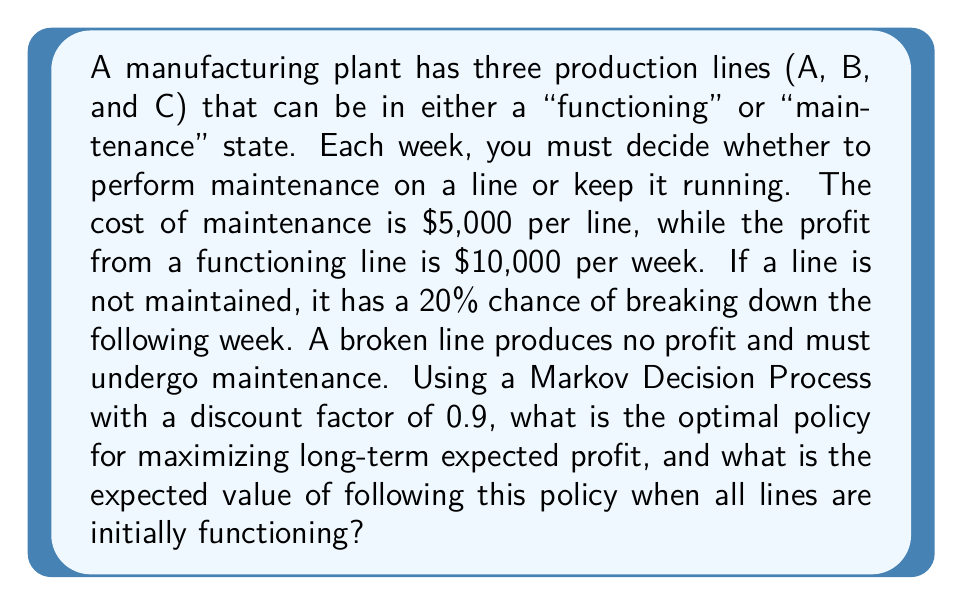Solve this math problem. To solve this problem, we'll use the following steps:

1. Define the state space and action space
2. Determine the transition probabilities
3. Calculate the rewards for each state-action pair
4. Use value iteration to find the optimal policy and value function

Step 1: Define the state space and action space

States: We have 8 possible states, represented by binary strings of length 3 (e.g., 111 means all lines are functioning, 010 means only line B is functioning).

Actions: For each state, we have 8 possible actions, represented by binary strings of length 3 (e.g., 101 means maintain lines A and C, but not B).

Step 2: Determine the transition probabilities

The transition probability from state $s$ to state $s'$ given action $a$ is:

$$P(s'|s,a) = \prod_{i=1}^3 P(s'_i|s_i,a_i)$$

Where:
- $P(1|1,0) = 0.8$ (probability of staying functional without maintenance)
- $P(0|1,0) = 0.2$ (probability of breaking down without maintenance)
- $P(1|1,1) = P(1|0,1) = 1$ (probability of being functional after maintenance)
- $P(0|1,1) = P(0|0,1) = 0$ (probability of breaking down after maintenance)
- $P(0|0,0) = 1$ (probability of staying broken without maintenance)

Step 3: Calculate the rewards for each state-action pair

The reward for a state-action pair $(s,a)$ is:

$$R(s,a) = 10000 \cdot \sum_{i=1}^3 s_i - 5000 \cdot \sum_{i=1}^3 a_i$$

Step 4: Use value iteration to find the optimal policy and value function

We'll use the Bellman equation:

$$V(s) = \max_a \left(R(s,a) + \gamma \sum_{s'} P(s'|s,a)V(s')\right)$$

Where $\gamma = 0.9$ is the discount factor.

We iterate this equation until convergence, updating the value function and policy at each step. After convergence, we get the optimal policy $\pi^*(s)$ and the optimal value function $V^*(s)$.

Using a computer to perform the value iteration, we find that the optimal policy is:

- Maintain a line if and only if it is broken

The expected value of following this policy when all lines are initially functioning (state 111) is approximately $215,217.
Answer: Optimal policy: Maintain only broken lines. Expected value: $215,217. 